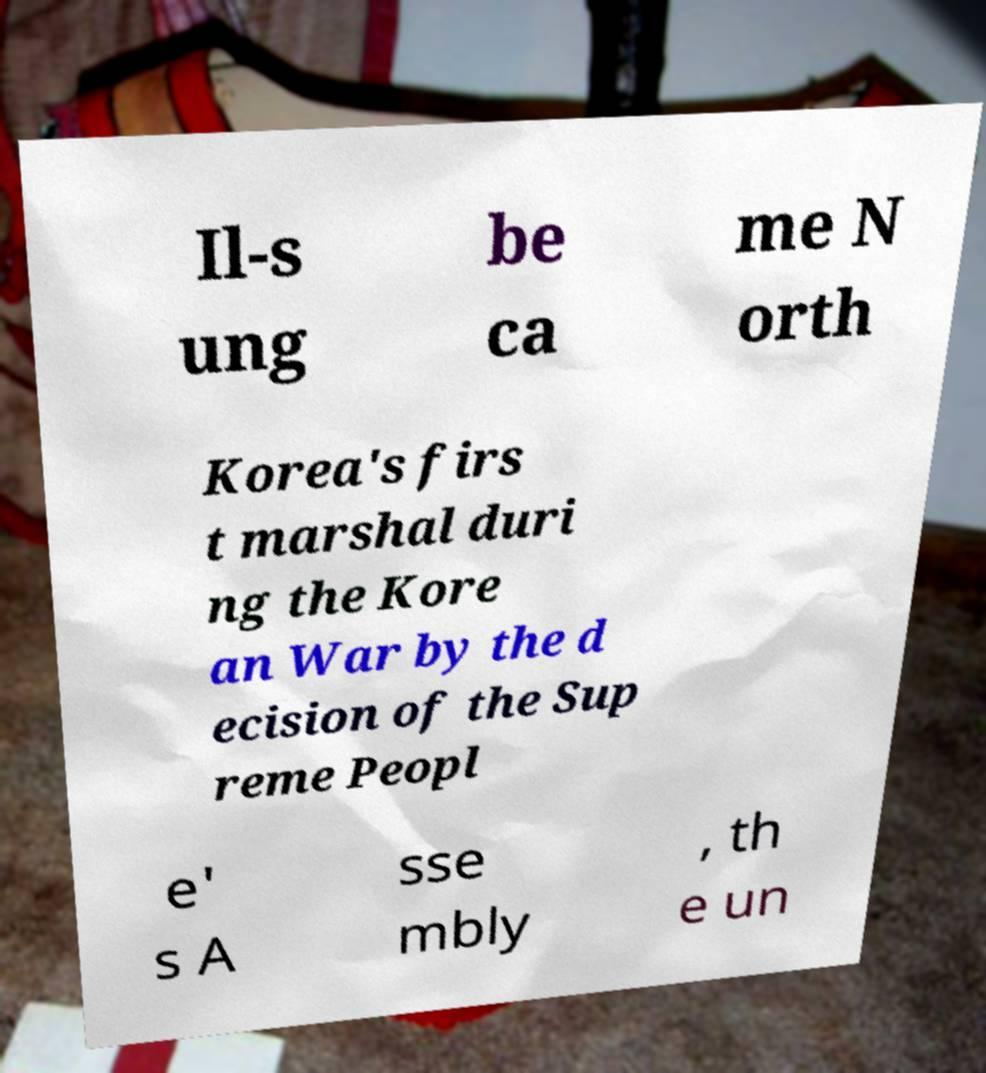Could you extract and type out the text from this image? Il-s ung be ca me N orth Korea's firs t marshal duri ng the Kore an War by the d ecision of the Sup reme Peopl e' s A sse mbly , th e un 